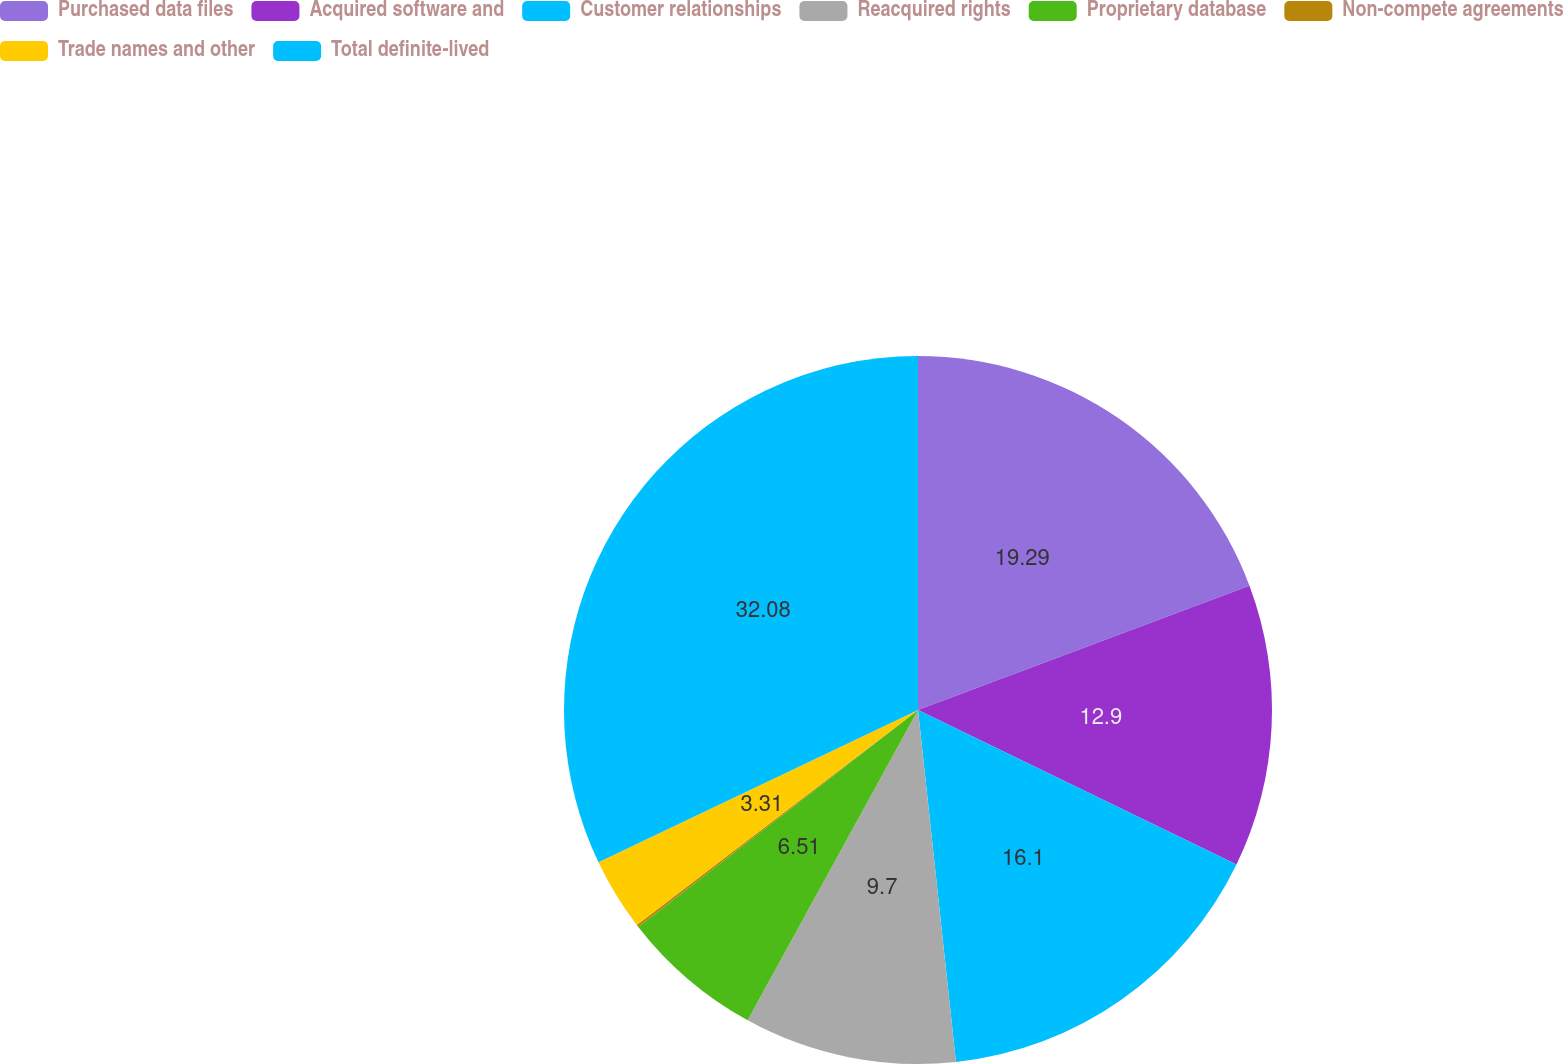Convert chart. <chart><loc_0><loc_0><loc_500><loc_500><pie_chart><fcel>Purchased data files<fcel>Acquired software and<fcel>Customer relationships<fcel>Reacquired rights<fcel>Proprietary database<fcel>Non-compete agreements<fcel>Trade names and other<fcel>Total definite-lived<nl><fcel>19.29%<fcel>12.9%<fcel>16.1%<fcel>9.7%<fcel>6.51%<fcel>0.11%<fcel>3.31%<fcel>32.08%<nl></chart> 